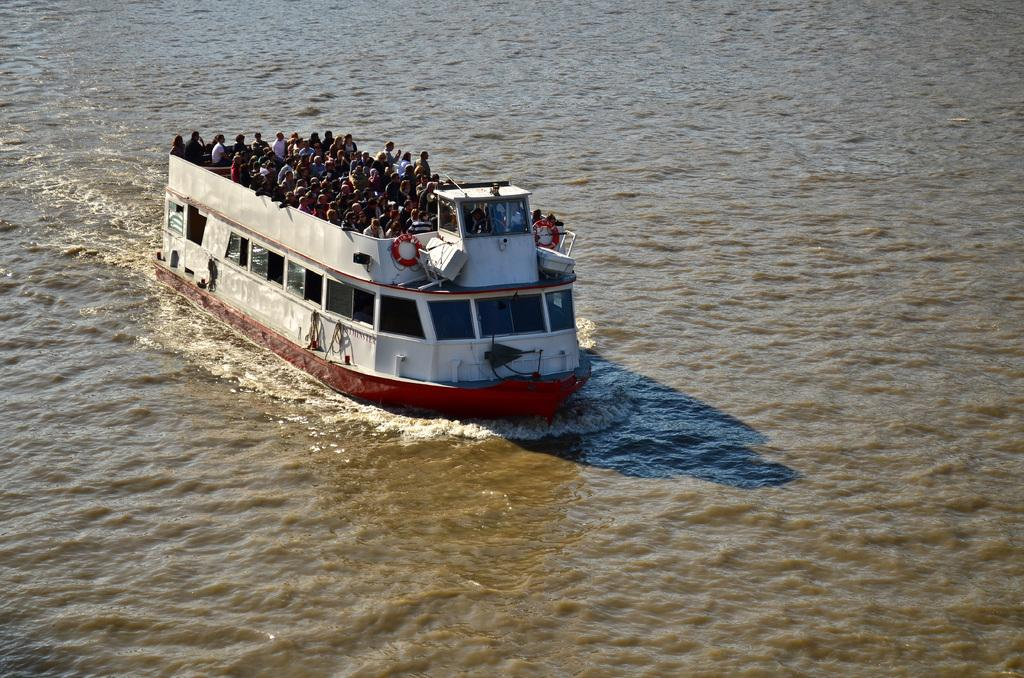What is the main subject of the image? The main subject of the image is a ship. What is the ship doing in the image? The ship is sailing on the water surface. Are there any passengers on the ship? Yes, there are people traveling on the ship. What type of pie is being served to the passengers on the ship? There is no information about pie being served on the ship in the image. 